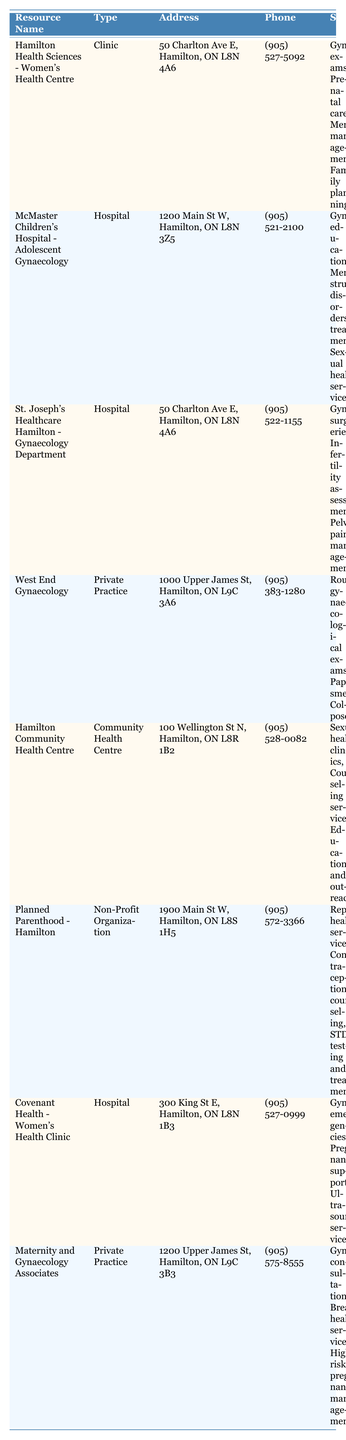What is the phone number for the Hamilton Health Sciences - Women's Health Centre? The phone number is listed directly in the table under the "Phone" column for that resource, which is (905) 527-5092.
Answer: (905) 527-5092 Which resource offers sexual health services? By scanning through the "Services" column, I find that both McMaster Children's Hospital - Adolescent Gynaecology and Planned Parenthood - Hamilton list "Sexual health services" and "STD testing and treatment" respectively.
Answer: McMaster Children's Hospital - Adolescent Gynaecology and Planned Parenthood - Hamilton How many hospitals are listed in the table? I can identify hospitals by checking the "Type" column and counting each entry marked as "Hospital." There are three hospitals: McMaster Children's Hospital - Adolescent Gynaecology, St. Joseph's Healthcare Hamilton - Gynaecology Department, and Covenant Health - Women's Health Clinic. Therefore, the total is 3.
Answer: 3 Which resource is located at 1000 Upper James St, Hamilton? The address 1000 Upper James St, Hamilton is found in the table alongside West End Gynaecology as its corresponding resource.
Answer: West End Gynaecology What services are offered at St. Joseph's Healthcare Hamilton - Gynaecology Department? Looking at the "Services" column for St. Joseph's Healthcare Hamilton - Gynaecology Department, the listed services are "Gynaecological surgeries," "Infertility assessments," and "Pelvic pain management."
Answer: Gynaecological surgeries, Infertility assessments, Pelvic pain management Does the Hamilton Community Health Centre provide counseling services? This can be verified by checking the "Services" column for Hamilton Community Health Centre, which states that it offers "Counseling services." Thus, the statement is true.
Answer: Yes Which resource has the most comprehensive range of services available? To determine this, I count the number of services listed for each resource. Hamilton Health Sciences - Women's Health Centre offers 4 services, while others such as St. Joseph's Healthcare Hamilton - Gynaecology Department and Planned Parenthood - Hamilton offer a lower number of services. Thus, Hamilton Health Sciences - Women's Health Centre has the most comprehensive range.
Answer: Hamilton Health Sciences - Women's Health Centre Is there a resource specifically addressing adolescent gynaecology? In the table, McMaster Children's Hospital - Adolescent Gynaecology is explicitly mentioned. Thus, there is indeed a resource for adolescent gynaecology.
Answer: Yes How many resources provide gynaecological exams? By scanning the "Services" column for each resource, I count that both Hamilton Health Sciences - Women's Health Centre and West End Gynaecology provide gynaecological exams, leading to a total of 2 resources.
Answer: 2 